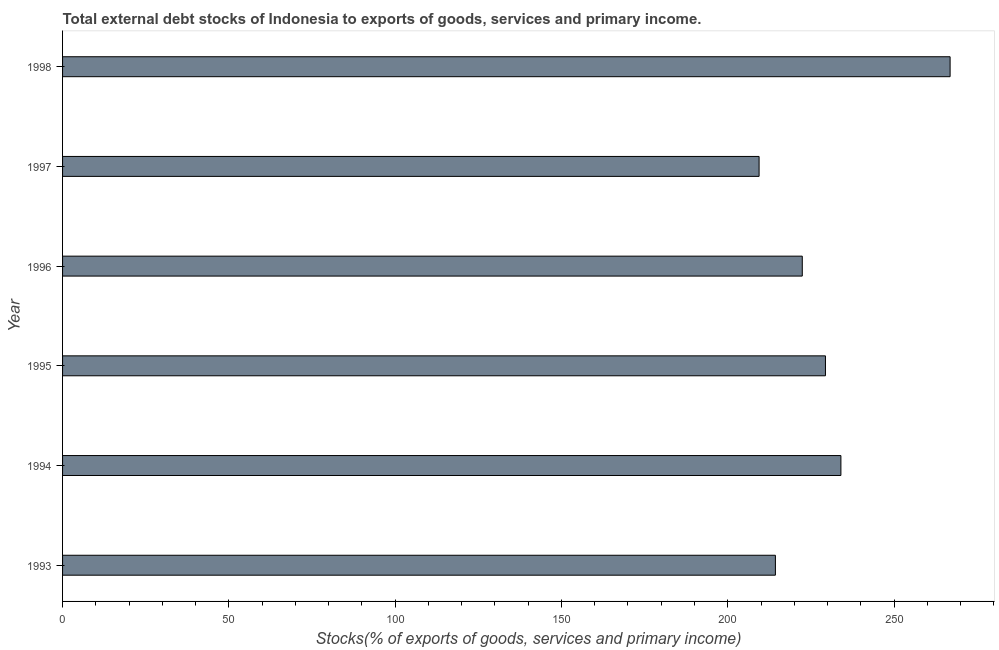Does the graph contain grids?
Your answer should be compact. No. What is the title of the graph?
Provide a short and direct response. Total external debt stocks of Indonesia to exports of goods, services and primary income. What is the label or title of the X-axis?
Ensure brevity in your answer.  Stocks(% of exports of goods, services and primary income). What is the external debt stocks in 1997?
Keep it short and to the point. 209.42. Across all years, what is the maximum external debt stocks?
Ensure brevity in your answer.  266.86. Across all years, what is the minimum external debt stocks?
Provide a short and direct response. 209.42. What is the sum of the external debt stocks?
Offer a terse response. 1376.41. What is the difference between the external debt stocks in 1994 and 1998?
Your answer should be very brief. -32.84. What is the average external debt stocks per year?
Your response must be concise. 229.4. What is the median external debt stocks?
Ensure brevity in your answer.  225.89. What is the ratio of the external debt stocks in 1993 to that in 1995?
Provide a succinct answer. 0.93. What is the difference between the highest and the second highest external debt stocks?
Make the answer very short. 32.84. What is the difference between the highest and the lowest external debt stocks?
Make the answer very short. 57.43. Are all the bars in the graph horizontal?
Keep it short and to the point. Yes. How many years are there in the graph?
Your answer should be compact. 6. What is the difference between two consecutive major ticks on the X-axis?
Provide a short and direct response. 50. What is the Stocks(% of exports of goods, services and primary income) of 1993?
Offer a terse response. 214.33. What is the Stocks(% of exports of goods, services and primary income) of 1994?
Provide a succinct answer. 234.02. What is the Stocks(% of exports of goods, services and primary income) of 1995?
Your answer should be compact. 229.38. What is the Stocks(% of exports of goods, services and primary income) in 1996?
Ensure brevity in your answer.  222.41. What is the Stocks(% of exports of goods, services and primary income) in 1997?
Provide a short and direct response. 209.42. What is the Stocks(% of exports of goods, services and primary income) in 1998?
Make the answer very short. 266.86. What is the difference between the Stocks(% of exports of goods, services and primary income) in 1993 and 1994?
Your answer should be very brief. -19.69. What is the difference between the Stocks(% of exports of goods, services and primary income) in 1993 and 1995?
Your answer should be very brief. -15.05. What is the difference between the Stocks(% of exports of goods, services and primary income) in 1993 and 1996?
Provide a succinct answer. -8.08. What is the difference between the Stocks(% of exports of goods, services and primary income) in 1993 and 1997?
Your answer should be very brief. 4.9. What is the difference between the Stocks(% of exports of goods, services and primary income) in 1993 and 1998?
Offer a very short reply. -52.53. What is the difference between the Stocks(% of exports of goods, services and primary income) in 1994 and 1995?
Keep it short and to the point. 4.64. What is the difference between the Stocks(% of exports of goods, services and primary income) in 1994 and 1996?
Provide a short and direct response. 11.62. What is the difference between the Stocks(% of exports of goods, services and primary income) in 1994 and 1997?
Keep it short and to the point. 24.6. What is the difference between the Stocks(% of exports of goods, services and primary income) in 1994 and 1998?
Give a very brief answer. -32.83. What is the difference between the Stocks(% of exports of goods, services and primary income) in 1995 and 1996?
Provide a succinct answer. 6.97. What is the difference between the Stocks(% of exports of goods, services and primary income) in 1995 and 1997?
Ensure brevity in your answer.  19.95. What is the difference between the Stocks(% of exports of goods, services and primary income) in 1995 and 1998?
Offer a terse response. -37.48. What is the difference between the Stocks(% of exports of goods, services and primary income) in 1996 and 1997?
Provide a succinct answer. 12.98. What is the difference between the Stocks(% of exports of goods, services and primary income) in 1996 and 1998?
Offer a terse response. -44.45. What is the difference between the Stocks(% of exports of goods, services and primary income) in 1997 and 1998?
Make the answer very short. -57.43. What is the ratio of the Stocks(% of exports of goods, services and primary income) in 1993 to that in 1994?
Offer a terse response. 0.92. What is the ratio of the Stocks(% of exports of goods, services and primary income) in 1993 to that in 1995?
Give a very brief answer. 0.93. What is the ratio of the Stocks(% of exports of goods, services and primary income) in 1993 to that in 1997?
Your answer should be very brief. 1.02. What is the ratio of the Stocks(% of exports of goods, services and primary income) in 1993 to that in 1998?
Make the answer very short. 0.8. What is the ratio of the Stocks(% of exports of goods, services and primary income) in 1994 to that in 1996?
Keep it short and to the point. 1.05. What is the ratio of the Stocks(% of exports of goods, services and primary income) in 1994 to that in 1997?
Keep it short and to the point. 1.12. What is the ratio of the Stocks(% of exports of goods, services and primary income) in 1994 to that in 1998?
Your answer should be very brief. 0.88. What is the ratio of the Stocks(% of exports of goods, services and primary income) in 1995 to that in 1996?
Ensure brevity in your answer.  1.03. What is the ratio of the Stocks(% of exports of goods, services and primary income) in 1995 to that in 1997?
Your response must be concise. 1.09. What is the ratio of the Stocks(% of exports of goods, services and primary income) in 1995 to that in 1998?
Give a very brief answer. 0.86. What is the ratio of the Stocks(% of exports of goods, services and primary income) in 1996 to that in 1997?
Your answer should be very brief. 1.06. What is the ratio of the Stocks(% of exports of goods, services and primary income) in 1996 to that in 1998?
Make the answer very short. 0.83. What is the ratio of the Stocks(% of exports of goods, services and primary income) in 1997 to that in 1998?
Provide a short and direct response. 0.79. 